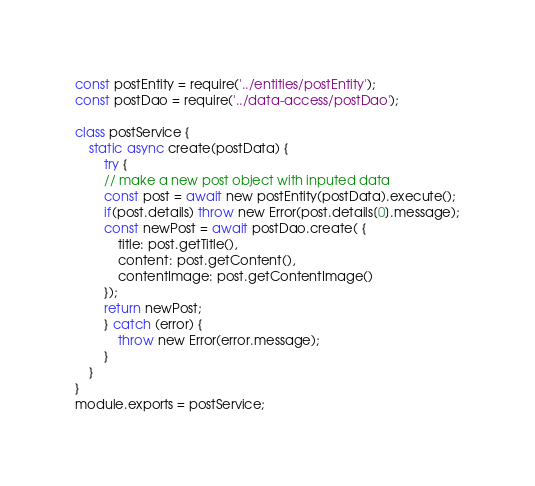Convert code to text. <code><loc_0><loc_0><loc_500><loc_500><_JavaScript_>const postEntity = require('../entities/postEntity');
const postDao = require('../data-access/postDao');

class postService {
    static async create(postData) {
        try {
        // make a new post object with inputed data
        const post = await new postEntity(postData).execute();
        if(post.details) throw new Error(post.details[0].message);
        const newPost = await postDao.create( {
            title: post.getTitle(),
            content: post.getContent(),
            contentImage: post.getContentImage()
        });
        return newPost;
        } catch (error) {
            throw new Error(error.message);
        }
    }
}
module.exports = postService;</code> 